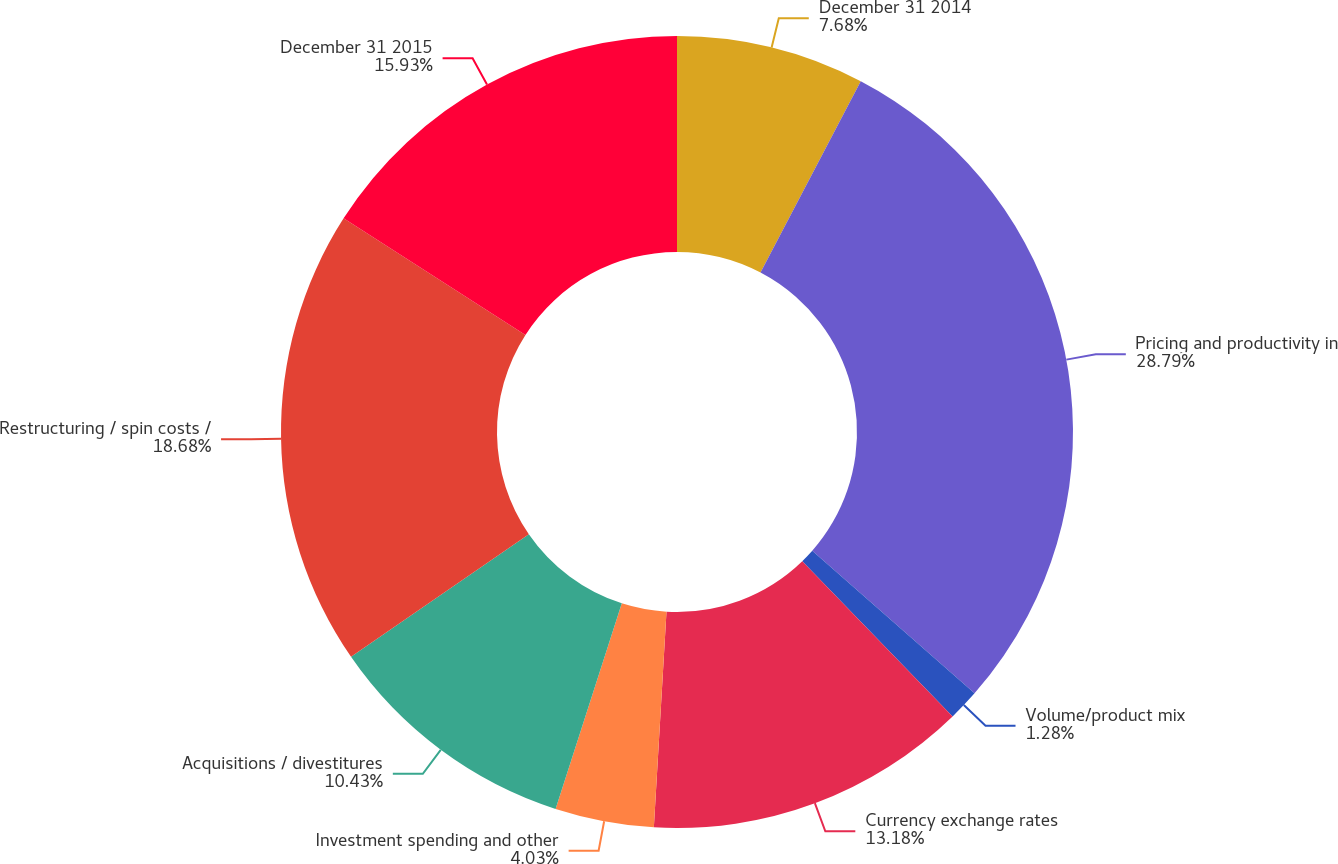<chart> <loc_0><loc_0><loc_500><loc_500><pie_chart><fcel>December 31 2014<fcel>Pricing and productivity in<fcel>Volume/product mix<fcel>Currency exchange rates<fcel>Investment spending and other<fcel>Acquisitions / divestitures<fcel>Restructuring / spin costs /<fcel>December 31 2015<nl><fcel>7.68%<fcel>28.79%<fcel>1.28%<fcel>13.18%<fcel>4.03%<fcel>10.43%<fcel>18.68%<fcel>15.93%<nl></chart> 